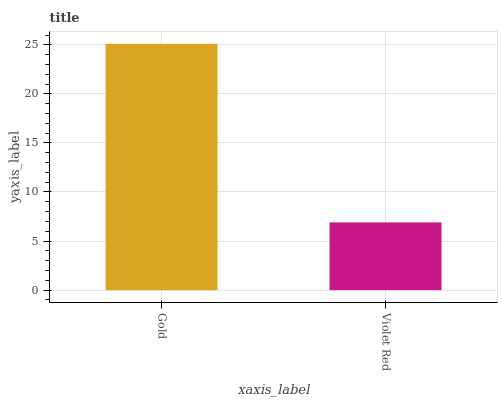Is Violet Red the minimum?
Answer yes or no. Yes. Is Gold the maximum?
Answer yes or no. Yes. Is Violet Red the maximum?
Answer yes or no. No. Is Gold greater than Violet Red?
Answer yes or no. Yes. Is Violet Red less than Gold?
Answer yes or no. Yes. Is Violet Red greater than Gold?
Answer yes or no. No. Is Gold less than Violet Red?
Answer yes or no. No. Is Gold the high median?
Answer yes or no. Yes. Is Violet Red the low median?
Answer yes or no. Yes. Is Violet Red the high median?
Answer yes or no. No. Is Gold the low median?
Answer yes or no. No. 